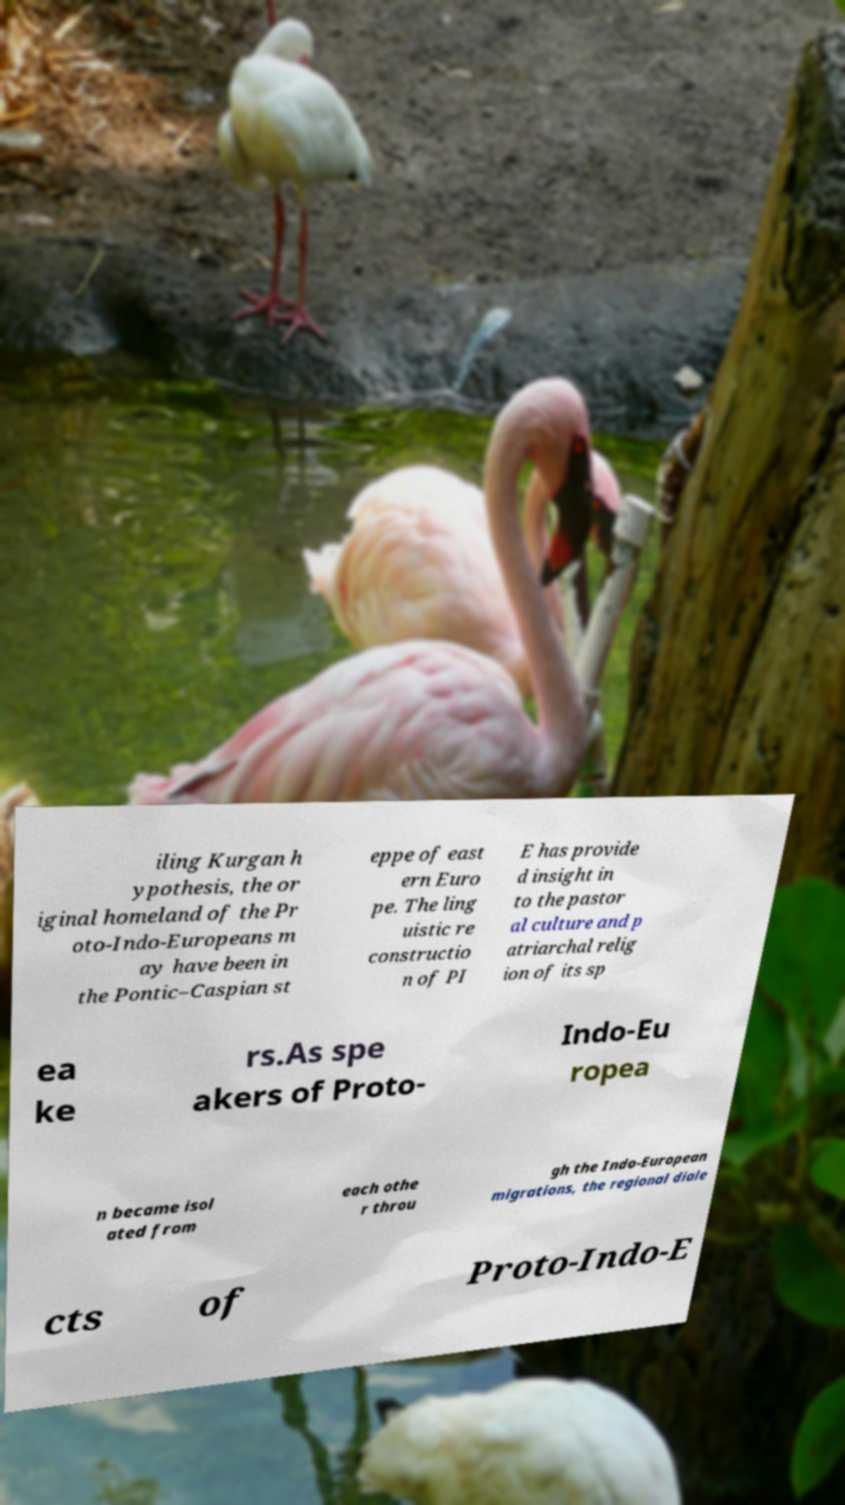There's text embedded in this image that I need extracted. Can you transcribe it verbatim? iling Kurgan h ypothesis, the or iginal homeland of the Pr oto-Indo-Europeans m ay have been in the Pontic–Caspian st eppe of east ern Euro pe. The ling uistic re constructio n of PI E has provide d insight in to the pastor al culture and p atriarchal relig ion of its sp ea ke rs.As spe akers of Proto- Indo-Eu ropea n became isol ated from each othe r throu gh the Indo-European migrations, the regional diale cts of Proto-Indo-E 